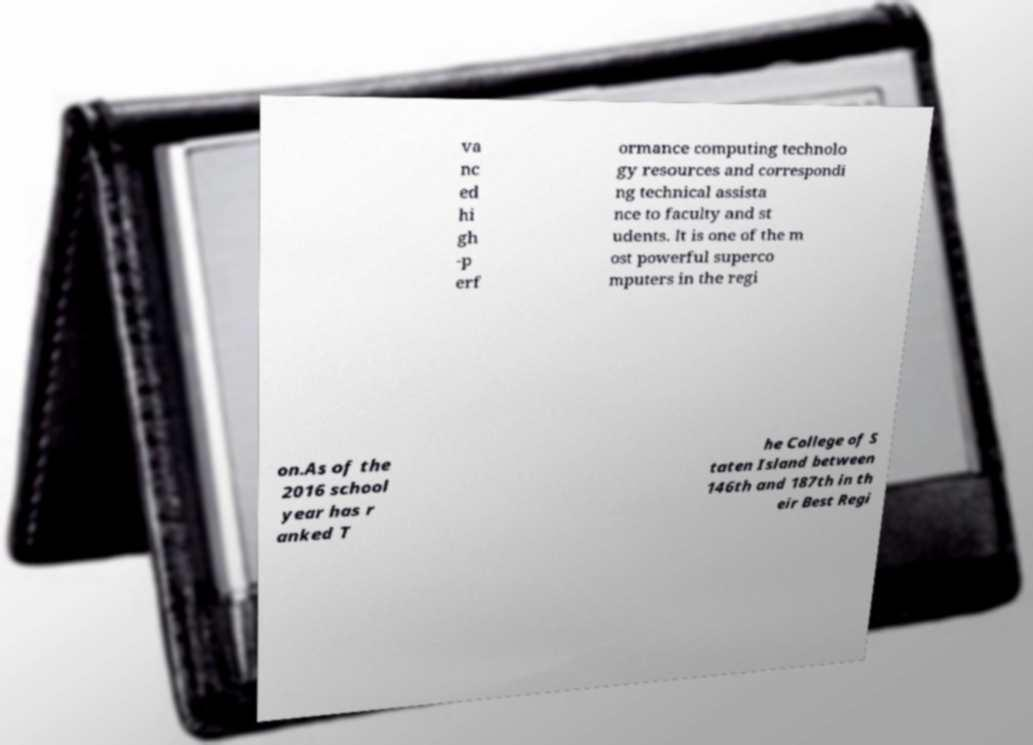Please read and relay the text visible in this image. What does it say? va nc ed hi gh -p erf ormance computing technolo gy resources and correspondi ng technical assista nce to faculty and st udents. It is one of the m ost powerful superco mputers in the regi on.As of the 2016 school year has r anked T he College of S taten Island between 146th and 187th in th eir Best Regi 